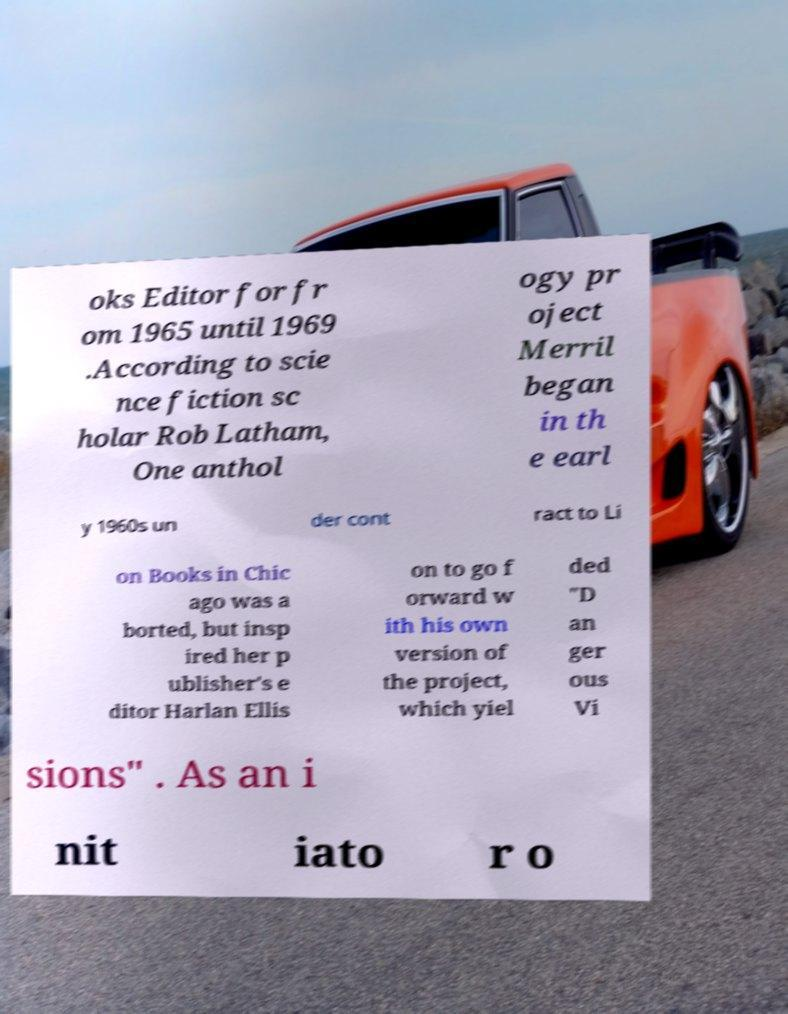What messages or text are displayed in this image? I need them in a readable, typed format. oks Editor for fr om 1965 until 1969 .According to scie nce fiction sc holar Rob Latham, One anthol ogy pr oject Merril began in th e earl y 1960s un der cont ract to Li on Books in Chic ago was a borted, but insp ired her p ublisher's e ditor Harlan Ellis on to go f orward w ith his own version of the project, which yiel ded "D an ger ous Vi sions" . As an i nit iato r o 